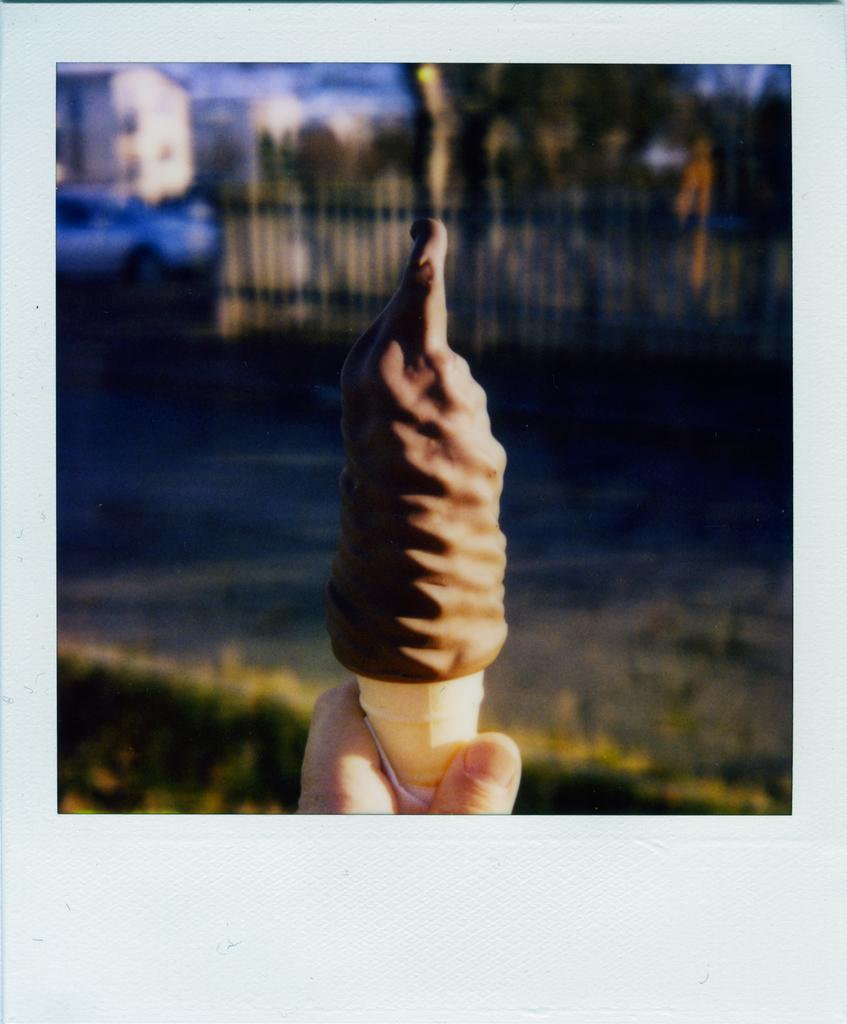What is the main subject in the center of the image? There is an ice cream in the center of the image. How is the ice cream being held? The ice cream is being held in a hand. What can be seen in the background of the image? Houses, trees, a boundary, and a vehicle are visible in the background of the image. What type of toys can be seen on the slope in the image? There is no slope or toys present in the image. 